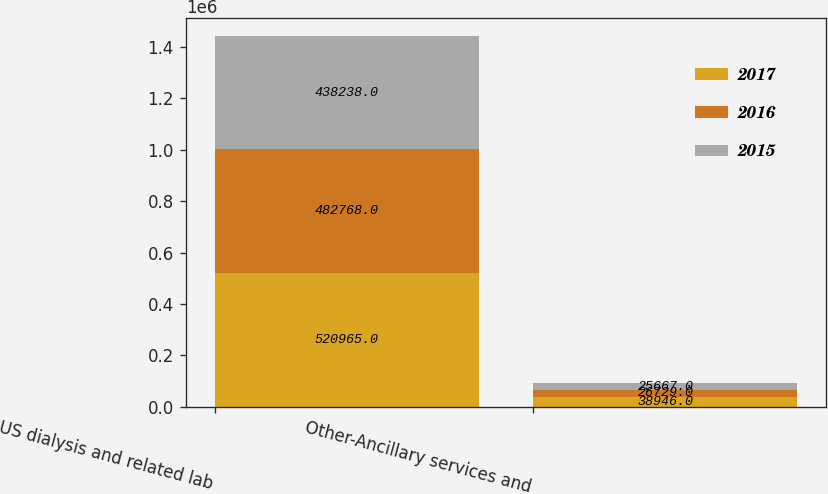Convert chart. <chart><loc_0><loc_0><loc_500><loc_500><stacked_bar_chart><ecel><fcel>US dialysis and related lab<fcel>Other-Ancillary services and<nl><fcel>2017<fcel>520965<fcel>38946<nl><fcel>2016<fcel>482768<fcel>26729<nl><fcel>2015<fcel>438238<fcel>25667<nl></chart> 